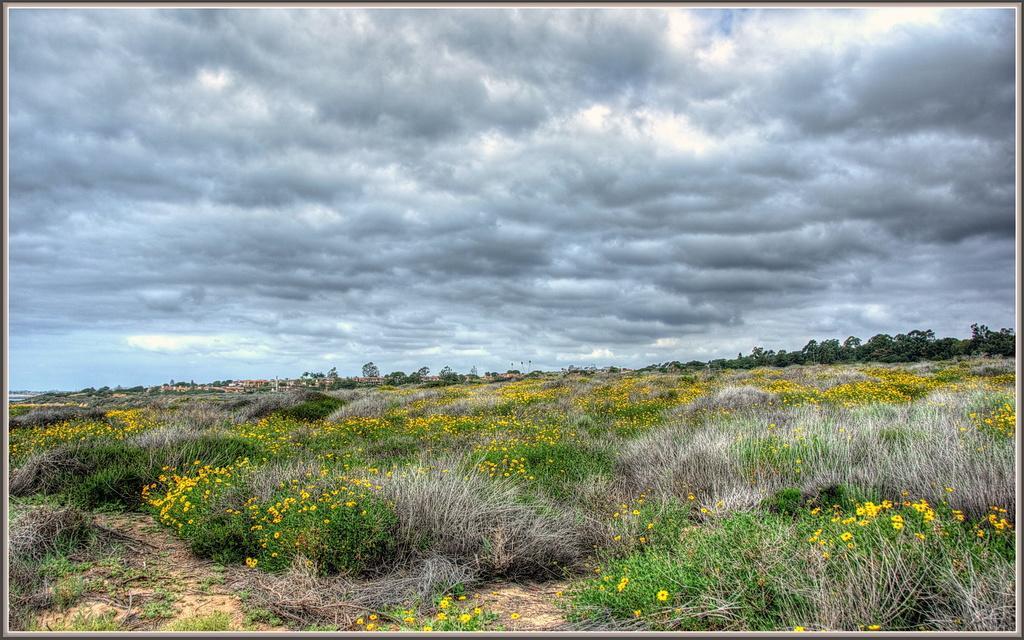Please provide a concise description of this image. Here in this picture we can see the ground is fully covered with grass and plants all over there and we can also see some flowers present on the plants over there and in the far we can see trees also present over there and we can see the sky is fully covered with clouds over there. 